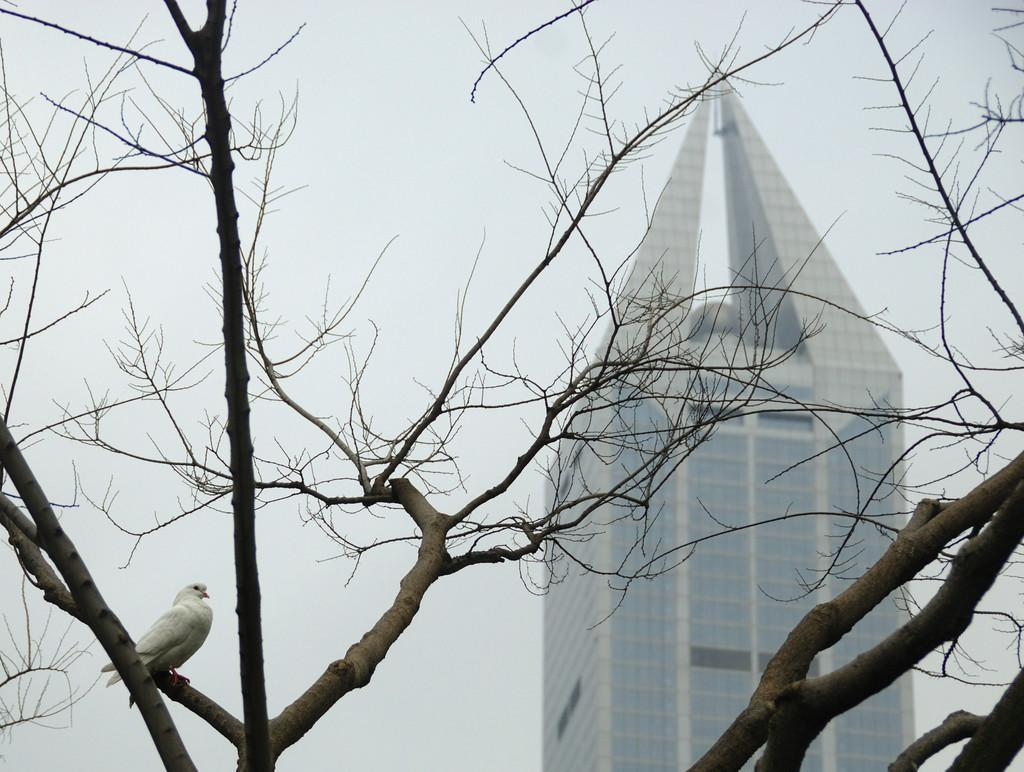What type of vegetation can be seen in the image? There are trees in the image. What kind of bird is present in the image? There is a white-colored bird in the image. What can be seen in the background of the image? The sky and a building are visible in the background of the image. Can you see a boot on the bird's foot in the image? There is no boot present on the bird's foot in the image. Is there a trail visible in the image? There is no trail visible in the image. 